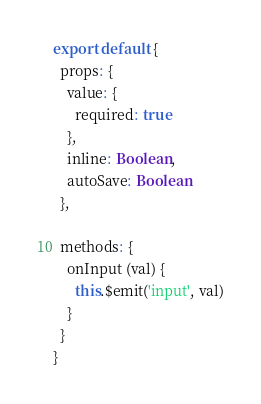Convert code to text. <code><loc_0><loc_0><loc_500><loc_500><_JavaScript_>export default {
  props: {
    value: {
      required: true
    },
    inline: Boolean,
    autoSave: Boolean
  },

  methods: {
    onInput (val) {
      this.$emit('input', val)
    }
  }
}
</code> 